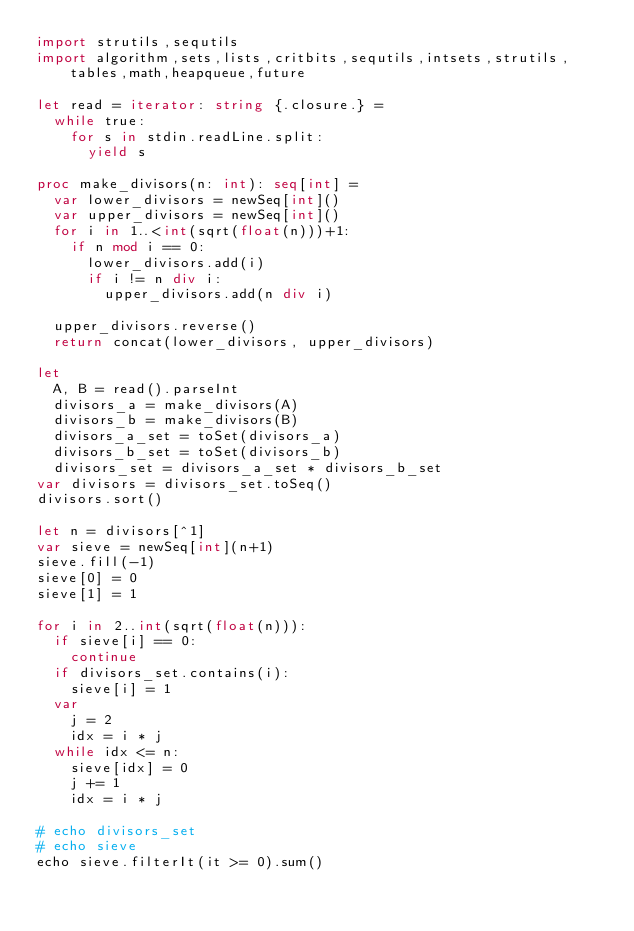<code> <loc_0><loc_0><loc_500><loc_500><_Nim_>import strutils,sequtils
import algorithm,sets,lists,critbits,sequtils,intsets,strutils,tables,math,heapqueue,future

let read = iterator: string {.closure.} =
  while true:
    for s in stdin.readLine.split:
      yield s

proc make_divisors(n: int): seq[int] = 
  var lower_divisors = newSeq[int]()
  var upper_divisors = newSeq[int]()
  for i in 1..<int(sqrt(float(n)))+1:
    if n mod i == 0:
      lower_divisors.add(i)
      if i != n div i:
        upper_divisors.add(n div i)

  upper_divisors.reverse()
  return concat(lower_divisors, upper_divisors)

let
  A, B = read().parseInt
  divisors_a = make_divisors(A)
  divisors_b = make_divisors(B)
  divisors_a_set = toSet(divisors_a)
  divisors_b_set = toSet(divisors_b)
  divisors_set = divisors_a_set * divisors_b_set
var divisors = divisors_set.toSeq()
divisors.sort()

let n = divisors[^1]
var sieve = newSeq[int](n+1)
sieve.fill(-1)
sieve[0] = 0
sieve[1] = 1

for i in 2..int(sqrt(float(n))):
  if sieve[i] == 0:
    continue
  if divisors_set.contains(i):
    sieve[i] = 1
  var
    j = 2
    idx = i * j 
  while idx <= n:
    sieve[idx] = 0
    j += 1
    idx = i * j 

# echo divisors_set
# echo sieve
echo sieve.filterIt(it >= 0).sum()
</code> 